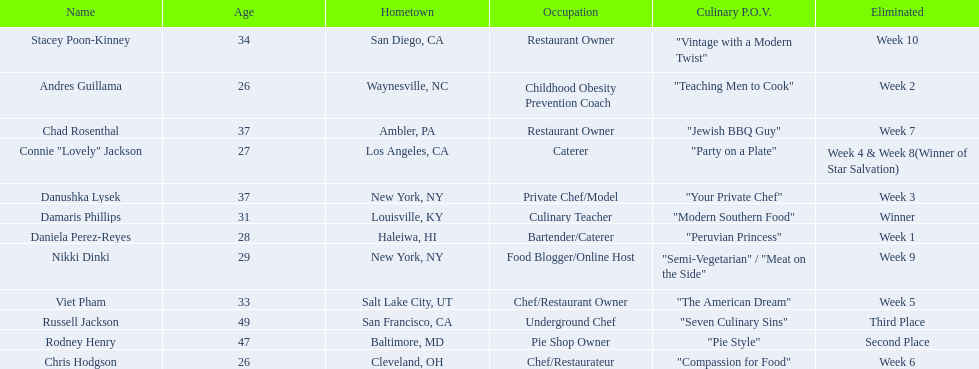Who are the contestants? Damaris Phillips, 31, Rodney Henry, 47, Russell Jackson, 49, Stacey Poon-Kinney, 34, Nikki Dinki, 29, Chad Rosenthal, 37, Chris Hodgson, 26, Viet Pham, 33, Connie "Lovely" Jackson, 27, Danushka Lysek, 37, Andres Guillama, 26, Daniela Perez-Reyes, 28. How old is chris hodgson? 26. Which other contestant has that age? Andres Guillama. Could you parse the entire table as a dict? {'header': ['Name', 'Age', 'Hometown', 'Occupation', 'Culinary P.O.V.', 'Eliminated'], 'rows': [['Stacey Poon-Kinney', '34', 'San Diego, CA', 'Restaurant Owner', '"Vintage with a Modern Twist"', 'Week 10'], ['Andres Guillama', '26', 'Waynesville, NC', 'Childhood Obesity Prevention Coach', '"Teaching Men to Cook"', 'Week 2'], ['Chad Rosenthal', '37', 'Ambler, PA', 'Restaurant Owner', '"Jewish BBQ Guy"', 'Week 7'], ['Connie "Lovely" Jackson', '27', 'Los Angeles, CA', 'Caterer', '"Party on a Plate"', 'Week 4 & Week 8(Winner of Star Salvation)'], ['Danushka Lysek', '37', 'New York, NY', 'Private Chef/Model', '"Your Private Chef"', 'Week 3'], ['Damaris Phillips', '31', 'Louisville, KY', 'Culinary Teacher', '"Modern Southern Food"', 'Winner'], ['Daniela Perez-Reyes', '28', 'Haleiwa, HI', 'Bartender/Caterer', '"Peruvian Princess"', 'Week 1'], ['Nikki Dinki', '29', 'New York, NY', 'Food Blogger/Online Host', '"Semi-Vegetarian" / "Meat on the Side"', 'Week 9'], ['Viet Pham', '33', 'Salt Lake City, UT', 'Chef/Restaurant Owner', '"The American Dream"', 'Week 5'], ['Russell Jackson', '49', 'San Francisco, CA', 'Underground Chef', '"Seven Culinary Sins"', 'Third Place'], ['Rodney Henry', '47', 'Baltimore, MD', 'Pie Shop Owner', '"Pie Style"', 'Second Place'], ['Chris Hodgson', '26', 'Cleveland, OH', 'Chef/Restaurateur', '"Compassion for Food"', 'Week 6']]} 